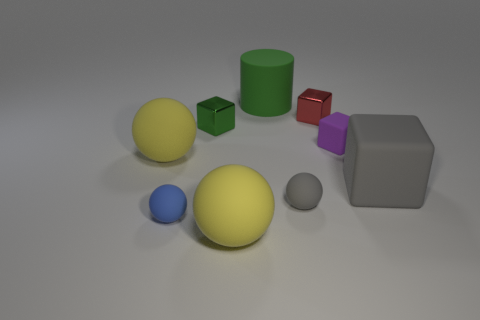Subtract all big gray matte cubes. How many cubes are left? 3 Subtract all purple blocks. How many yellow spheres are left? 2 Subtract all gray balls. How many balls are left? 3 Subtract all blocks. How many objects are left? 5 Subtract 2 blocks. How many blocks are left? 2 Subtract all purple cylinders. Subtract all yellow spheres. How many cylinders are left? 1 Subtract all tiny gray things. Subtract all small green metallic objects. How many objects are left? 7 Add 9 big gray blocks. How many big gray blocks are left? 10 Add 1 small gray things. How many small gray things exist? 2 Subtract 0 yellow cubes. How many objects are left? 9 